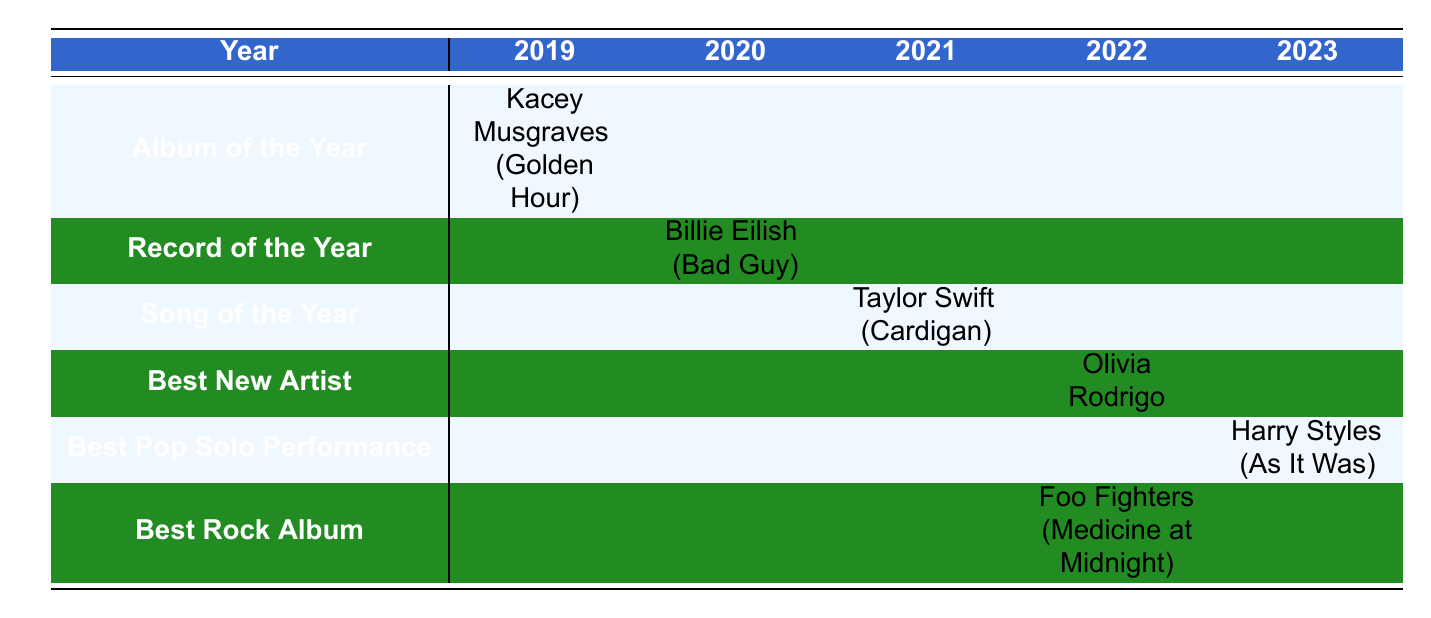What artist won Album of the Year in 2019? Referring to the 2019 column under the Album of the Year row, Kacey Musgraves is listed as the winner.
Answer: Kacey Musgraves Which song won Record of the Year in 2020? Looking at the 2020 column under the Record of the Year row, Billie Eilish's song "Bad Guy" is noted as the winner.
Answer: Bad Guy Is Olivia Rodrigo the winner of Best New Artist in 2022? The table indicates that Olivia Rodrigo is listed under the Best New Artist category for 2022, confirming her win in this category.
Answer: Yes How many awards did Taylor Swift win in the given years? Taylor Swift is listed as the winner for Song of the Year in 2021. She is not mentioned in other years, so she won one award.
Answer: 1 Which artist won Best Rock Album in 2022 and what was the name of the album? The row for Best Rock Album in 2022 shows Foo Fighters as the winner and the album is titled "Medicine at Midnight".
Answer: Foo Fighters (Medicine at Midnight) In which year did Harry Styles win an award, and in what category? The row for Best Pop Solo Performance indicates that Harry Styles won in 2023. The category for his award is Best Pop Solo Performance.
Answer: 2023, Best Pop Solo Performance Did any artist win an award for Best New Artist before 2022? The table specifically shows that the only winner listed under Best New Artist is Olivia Rodrigo for 2022, indicating no artist won before that year.
Answer: No What is the total number of different categories represented in the table? The categories listed are Album of the Year, Record of the Year, Song of the Year, Best New Artist, Best Pop Solo Performance, and Best Rock Album. This totals to six different categories.
Answer: 6 In sequential order by year, what are the winning artists' names? The winners by year are Kacey Musgraves (2019), Billie Eilish (2020), Taylor Swift (2021), Olivia Rodrigo (2022), and Harry Styles (2023). Compiling these names provides the list needed.
Answer: Kacey Musgraves, Billie Eilish, Taylor Swift, Olivia Rodrigo, Harry Styles 